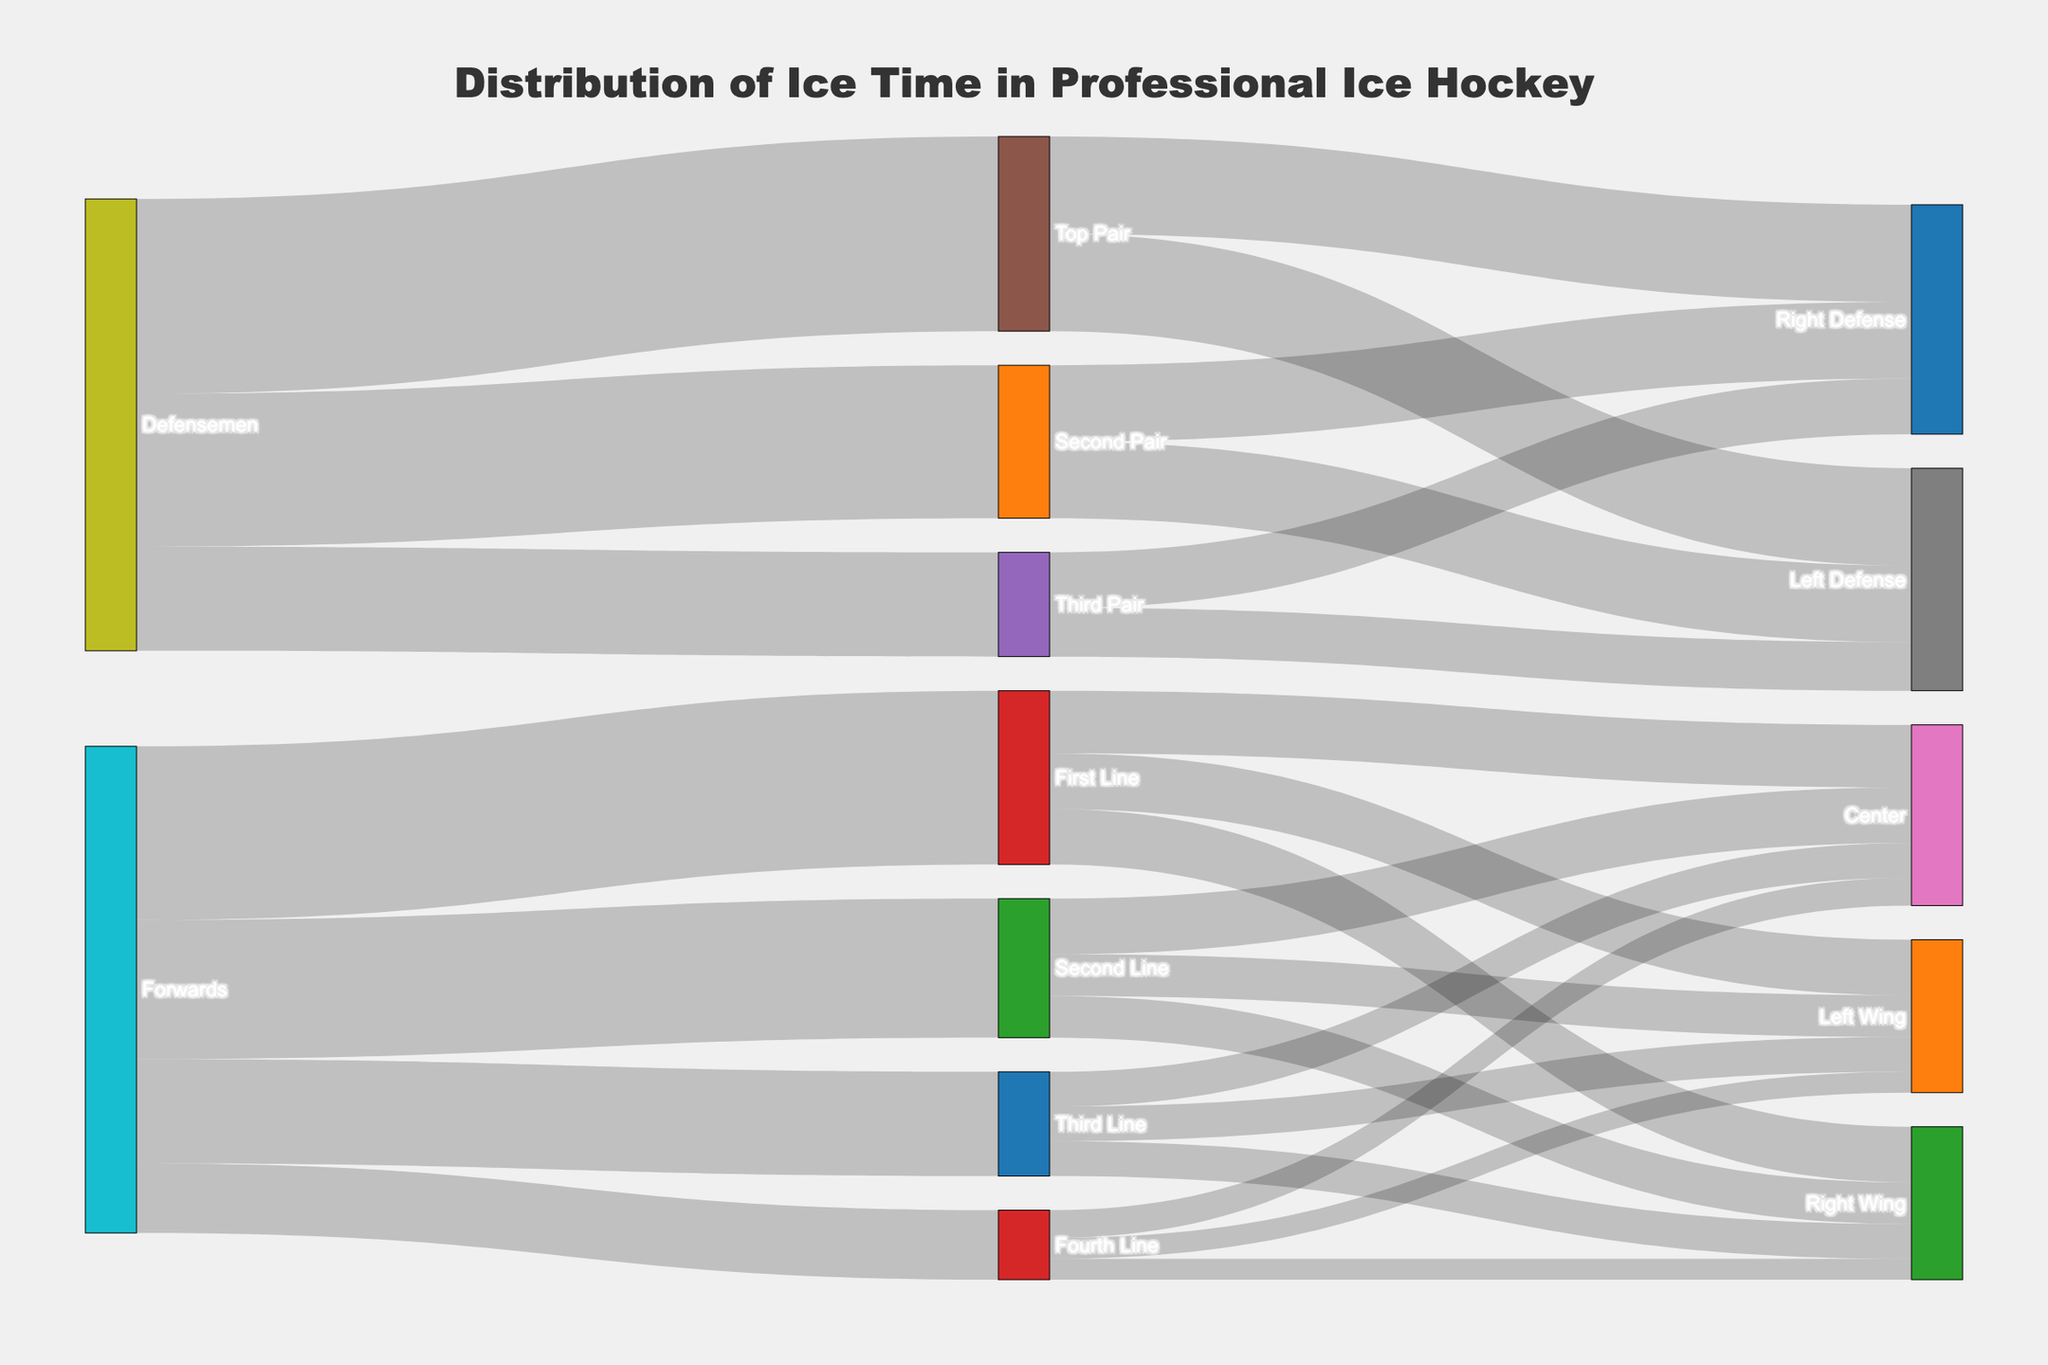What is the title of the Sankey Diagram? The title is present at the top center of the diagram. It clearly labels the diagram's purpose.
Answer: Distribution of Ice Time in Professional Ice Hockey Which category of players has the highest total ice time on the ice? Summing the values connected to "Forwards" and "Defensemen", Forwards have (25+20+15+10)=70 and Defensemen have (28+22+15)=65. Forwards have more.
Answer: Forwards How much ice time is distributed among the fourth line players? Summing the values of Left Wing, Center, and Right Wing under "Fourth Line" gives (3+4+3)=10.
Answer: 10 Compare the ice time between the First Line and the Second Pair defensemen. Which one has more? The total ice time for First Line is (8+9+8)=25 and for Second Pair is (11+11)=22. The First Line has more ice time.
Answer: First Line How is the ice time for the Defensemen split among different pairs? Top Pair: 28, Second Pair: 22, Third Pair: 15.
Answer: 28, 22, 15 What is the total ice time for Centers across all lines? Summing the values for Centers in First Line (9), Second Line (8), Third Line (5), and Fourth Line (4): 9+8+5+4=26.
Answer: 26 Which position under Forwards spends the least ice time, and how much? From the links under Forwards, Fourth Line has the least total ice time of 10 minutes.
Answer: Fourth Line, 10 What is the total ice time for Left Defense positions? Summing the Left Defense positions for Top (14), Second (11), and Third Pairs (7): 14+11+7=32.
Answer: 32 How does the ice time of Right Wing players on the First Line compare to the Right Defense on the Third Pair? Right Wing on the First Line: 8; Right Defense on the Third Pair: 8. They are equal.
Answer: Equal Which has a greater ice time: the Third Line forwards or the Third Pair defensemen? Third Line forwards total (5+5+5)=15, and Third Pair defensemen total (7+8)=15. They are equal.
Answer: Equal 